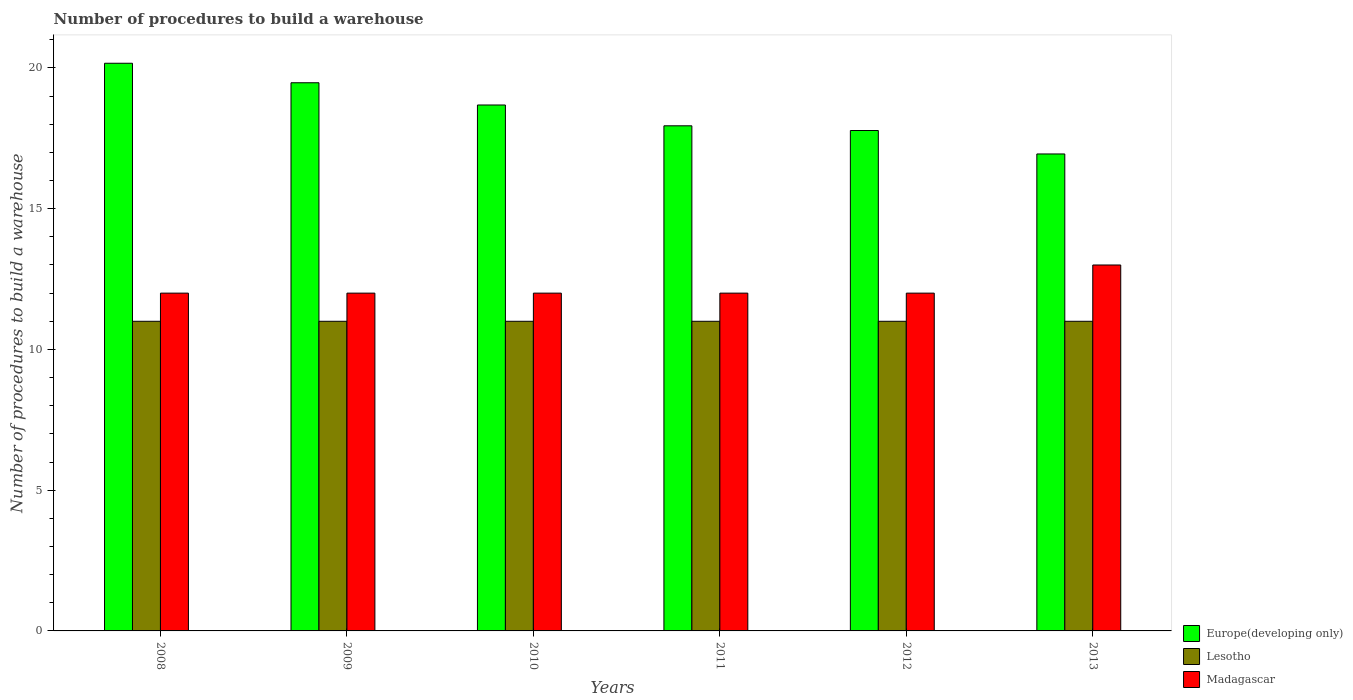How many different coloured bars are there?
Your response must be concise. 3. How many groups of bars are there?
Ensure brevity in your answer.  6. Are the number of bars per tick equal to the number of legend labels?
Ensure brevity in your answer.  Yes. Are the number of bars on each tick of the X-axis equal?
Ensure brevity in your answer.  Yes. How many bars are there on the 5th tick from the left?
Give a very brief answer. 3. What is the label of the 3rd group of bars from the left?
Ensure brevity in your answer.  2010. In how many cases, is the number of bars for a given year not equal to the number of legend labels?
Your response must be concise. 0. What is the number of procedures to build a warehouse in in Madagascar in 2009?
Ensure brevity in your answer.  12. Across all years, what is the maximum number of procedures to build a warehouse in in Madagascar?
Your answer should be compact. 13. Across all years, what is the minimum number of procedures to build a warehouse in in Europe(developing only)?
Your answer should be compact. 16.94. In which year was the number of procedures to build a warehouse in in Madagascar maximum?
Provide a short and direct response. 2013. What is the total number of procedures to build a warehouse in in Europe(developing only) in the graph?
Offer a terse response. 110.99. What is the difference between the number of procedures to build a warehouse in in Europe(developing only) in 2009 and that in 2011?
Provide a succinct answer. 1.53. What is the difference between the number of procedures to build a warehouse in in Madagascar in 2008 and the number of procedures to build a warehouse in in Europe(developing only) in 2012?
Your answer should be compact. -5.78. What is the average number of procedures to build a warehouse in in Madagascar per year?
Keep it short and to the point. 12.17. In the year 2008, what is the difference between the number of procedures to build a warehouse in in Europe(developing only) and number of procedures to build a warehouse in in Madagascar?
Ensure brevity in your answer.  8.17. In how many years, is the number of procedures to build a warehouse in in Lesotho greater than 3?
Provide a short and direct response. 6. What is the ratio of the number of procedures to build a warehouse in in Europe(developing only) in 2011 to that in 2012?
Your answer should be very brief. 1.01. Is the number of procedures to build a warehouse in in Lesotho in 2010 less than that in 2011?
Your answer should be compact. No. Is the difference between the number of procedures to build a warehouse in in Europe(developing only) in 2009 and 2011 greater than the difference between the number of procedures to build a warehouse in in Madagascar in 2009 and 2011?
Your response must be concise. Yes. What is the difference between the highest and the lowest number of procedures to build a warehouse in in Madagascar?
Ensure brevity in your answer.  1. In how many years, is the number of procedures to build a warehouse in in Madagascar greater than the average number of procedures to build a warehouse in in Madagascar taken over all years?
Ensure brevity in your answer.  1. Is the sum of the number of procedures to build a warehouse in in Lesotho in 2010 and 2013 greater than the maximum number of procedures to build a warehouse in in Madagascar across all years?
Provide a succinct answer. Yes. What does the 2nd bar from the left in 2013 represents?
Provide a succinct answer. Lesotho. What does the 2nd bar from the right in 2012 represents?
Provide a short and direct response. Lesotho. How many years are there in the graph?
Ensure brevity in your answer.  6. What is the difference between two consecutive major ticks on the Y-axis?
Keep it short and to the point. 5. Does the graph contain grids?
Provide a succinct answer. No. What is the title of the graph?
Offer a very short reply. Number of procedures to build a warehouse. Does "Congo (Republic)" appear as one of the legend labels in the graph?
Ensure brevity in your answer.  No. What is the label or title of the X-axis?
Offer a terse response. Years. What is the label or title of the Y-axis?
Your response must be concise. Number of procedures to build a warehouse. What is the Number of procedures to build a warehouse of Europe(developing only) in 2008?
Provide a succinct answer. 20.17. What is the Number of procedures to build a warehouse of Europe(developing only) in 2009?
Your response must be concise. 19.47. What is the Number of procedures to build a warehouse in Lesotho in 2009?
Your answer should be very brief. 11. What is the Number of procedures to build a warehouse in Madagascar in 2009?
Offer a terse response. 12. What is the Number of procedures to build a warehouse of Europe(developing only) in 2010?
Your response must be concise. 18.68. What is the Number of procedures to build a warehouse of Madagascar in 2010?
Make the answer very short. 12. What is the Number of procedures to build a warehouse of Europe(developing only) in 2011?
Your answer should be very brief. 17.94. What is the Number of procedures to build a warehouse of Lesotho in 2011?
Keep it short and to the point. 11. What is the Number of procedures to build a warehouse in Madagascar in 2011?
Provide a succinct answer. 12. What is the Number of procedures to build a warehouse of Europe(developing only) in 2012?
Offer a very short reply. 17.78. What is the Number of procedures to build a warehouse in Madagascar in 2012?
Your answer should be compact. 12. What is the Number of procedures to build a warehouse in Europe(developing only) in 2013?
Provide a succinct answer. 16.94. Across all years, what is the maximum Number of procedures to build a warehouse of Europe(developing only)?
Provide a succinct answer. 20.17. Across all years, what is the maximum Number of procedures to build a warehouse in Lesotho?
Your answer should be compact. 11. Across all years, what is the maximum Number of procedures to build a warehouse in Madagascar?
Your answer should be very brief. 13. Across all years, what is the minimum Number of procedures to build a warehouse in Europe(developing only)?
Your response must be concise. 16.94. Across all years, what is the minimum Number of procedures to build a warehouse of Lesotho?
Your answer should be compact. 11. Across all years, what is the minimum Number of procedures to build a warehouse of Madagascar?
Your answer should be compact. 12. What is the total Number of procedures to build a warehouse of Europe(developing only) in the graph?
Your response must be concise. 110.99. What is the total Number of procedures to build a warehouse of Lesotho in the graph?
Ensure brevity in your answer.  66. What is the difference between the Number of procedures to build a warehouse of Europe(developing only) in 2008 and that in 2009?
Provide a succinct answer. 0.69. What is the difference between the Number of procedures to build a warehouse in Madagascar in 2008 and that in 2009?
Ensure brevity in your answer.  0. What is the difference between the Number of procedures to build a warehouse in Europe(developing only) in 2008 and that in 2010?
Give a very brief answer. 1.48. What is the difference between the Number of procedures to build a warehouse in Europe(developing only) in 2008 and that in 2011?
Your answer should be very brief. 2.22. What is the difference between the Number of procedures to build a warehouse in Lesotho in 2008 and that in 2011?
Ensure brevity in your answer.  0. What is the difference between the Number of procedures to build a warehouse in Madagascar in 2008 and that in 2011?
Your answer should be compact. 0. What is the difference between the Number of procedures to build a warehouse of Europe(developing only) in 2008 and that in 2012?
Provide a short and direct response. 2.39. What is the difference between the Number of procedures to build a warehouse of Madagascar in 2008 and that in 2012?
Provide a succinct answer. 0. What is the difference between the Number of procedures to build a warehouse in Europe(developing only) in 2008 and that in 2013?
Make the answer very short. 3.22. What is the difference between the Number of procedures to build a warehouse of Madagascar in 2008 and that in 2013?
Your answer should be compact. -1. What is the difference between the Number of procedures to build a warehouse in Europe(developing only) in 2009 and that in 2010?
Ensure brevity in your answer.  0.79. What is the difference between the Number of procedures to build a warehouse in Lesotho in 2009 and that in 2010?
Your answer should be compact. 0. What is the difference between the Number of procedures to build a warehouse of Europe(developing only) in 2009 and that in 2011?
Your response must be concise. 1.53. What is the difference between the Number of procedures to build a warehouse in Lesotho in 2009 and that in 2011?
Keep it short and to the point. 0. What is the difference between the Number of procedures to build a warehouse of Europe(developing only) in 2009 and that in 2012?
Ensure brevity in your answer.  1.7. What is the difference between the Number of procedures to build a warehouse in Madagascar in 2009 and that in 2012?
Make the answer very short. 0. What is the difference between the Number of procedures to build a warehouse in Europe(developing only) in 2009 and that in 2013?
Your response must be concise. 2.53. What is the difference between the Number of procedures to build a warehouse in Lesotho in 2009 and that in 2013?
Offer a terse response. 0. What is the difference between the Number of procedures to build a warehouse of Europe(developing only) in 2010 and that in 2011?
Give a very brief answer. 0.74. What is the difference between the Number of procedures to build a warehouse in Lesotho in 2010 and that in 2011?
Provide a short and direct response. 0. What is the difference between the Number of procedures to build a warehouse in Madagascar in 2010 and that in 2011?
Make the answer very short. 0. What is the difference between the Number of procedures to build a warehouse in Europe(developing only) in 2010 and that in 2012?
Keep it short and to the point. 0.91. What is the difference between the Number of procedures to build a warehouse of Europe(developing only) in 2010 and that in 2013?
Make the answer very short. 1.74. What is the difference between the Number of procedures to build a warehouse of Lesotho in 2010 and that in 2013?
Your answer should be compact. 0. What is the difference between the Number of procedures to build a warehouse of Madagascar in 2010 and that in 2013?
Your answer should be very brief. -1. What is the difference between the Number of procedures to build a warehouse of Europe(developing only) in 2011 and that in 2012?
Offer a terse response. 0.17. What is the difference between the Number of procedures to build a warehouse of Lesotho in 2011 and that in 2012?
Your response must be concise. 0. What is the difference between the Number of procedures to build a warehouse in Madagascar in 2011 and that in 2012?
Give a very brief answer. 0. What is the difference between the Number of procedures to build a warehouse of Europe(developing only) in 2011 and that in 2013?
Your answer should be very brief. 1. What is the difference between the Number of procedures to build a warehouse in Madagascar in 2011 and that in 2013?
Your answer should be very brief. -1. What is the difference between the Number of procedures to build a warehouse of Lesotho in 2012 and that in 2013?
Your answer should be compact. 0. What is the difference between the Number of procedures to build a warehouse in Europe(developing only) in 2008 and the Number of procedures to build a warehouse in Lesotho in 2009?
Your answer should be compact. 9.17. What is the difference between the Number of procedures to build a warehouse in Europe(developing only) in 2008 and the Number of procedures to build a warehouse in Madagascar in 2009?
Give a very brief answer. 8.17. What is the difference between the Number of procedures to build a warehouse in Lesotho in 2008 and the Number of procedures to build a warehouse in Madagascar in 2009?
Offer a very short reply. -1. What is the difference between the Number of procedures to build a warehouse of Europe(developing only) in 2008 and the Number of procedures to build a warehouse of Lesotho in 2010?
Make the answer very short. 9.17. What is the difference between the Number of procedures to build a warehouse of Europe(developing only) in 2008 and the Number of procedures to build a warehouse of Madagascar in 2010?
Provide a succinct answer. 8.17. What is the difference between the Number of procedures to build a warehouse in Lesotho in 2008 and the Number of procedures to build a warehouse in Madagascar in 2010?
Give a very brief answer. -1. What is the difference between the Number of procedures to build a warehouse of Europe(developing only) in 2008 and the Number of procedures to build a warehouse of Lesotho in 2011?
Your answer should be very brief. 9.17. What is the difference between the Number of procedures to build a warehouse of Europe(developing only) in 2008 and the Number of procedures to build a warehouse of Madagascar in 2011?
Offer a terse response. 8.17. What is the difference between the Number of procedures to build a warehouse of Europe(developing only) in 2008 and the Number of procedures to build a warehouse of Lesotho in 2012?
Ensure brevity in your answer.  9.17. What is the difference between the Number of procedures to build a warehouse in Europe(developing only) in 2008 and the Number of procedures to build a warehouse in Madagascar in 2012?
Give a very brief answer. 8.17. What is the difference between the Number of procedures to build a warehouse of Europe(developing only) in 2008 and the Number of procedures to build a warehouse of Lesotho in 2013?
Offer a terse response. 9.17. What is the difference between the Number of procedures to build a warehouse in Europe(developing only) in 2008 and the Number of procedures to build a warehouse in Madagascar in 2013?
Keep it short and to the point. 7.17. What is the difference between the Number of procedures to build a warehouse of Lesotho in 2008 and the Number of procedures to build a warehouse of Madagascar in 2013?
Provide a short and direct response. -2. What is the difference between the Number of procedures to build a warehouse of Europe(developing only) in 2009 and the Number of procedures to build a warehouse of Lesotho in 2010?
Your response must be concise. 8.47. What is the difference between the Number of procedures to build a warehouse in Europe(developing only) in 2009 and the Number of procedures to build a warehouse in Madagascar in 2010?
Your response must be concise. 7.47. What is the difference between the Number of procedures to build a warehouse of Europe(developing only) in 2009 and the Number of procedures to build a warehouse of Lesotho in 2011?
Your answer should be very brief. 8.47. What is the difference between the Number of procedures to build a warehouse of Europe(developing only) in 2009 and the Number of procedures to build a warehouse of Madagascar in 2011?
Your response must be concise. 7.47. What is the difference between the Number of procedures to build a warehouse of Lesotho in 2009 and the Number of procedures to build a warehouse of Madagascar in 2011?
Ensure brevity in your answer.  -1. What is the difference between the Number of procedures to build a warehouse of Europe(developing only) in 2009 and the Number of procedures to build a warehouse of Lesotho in 2012?
Your response must be concise. 8.47. What is the difference between the Number of procedures to build a warehouse of Europe(developing only) in 2009 and the Number of procedures to build a warehouse of Madagascar in 2012?
Your response must be concise. 7.47. What is the difference between the Number of procedures to build a warehouse of Lesotho in 2009 and the Number of procedures to build a warehouse of Madagascar in 2012?
Your answer should be compact. -1. What is the difference between the Number of procedures to build a warehouse of Europe(developing only) in 2009 and the Number of procedures to build a warehouse of Lesotho in 2013?
Provide a short and direct response. 8.47. What is the difference between the Number of procedures to build a warehouse in Europe(developing only) in 2009 and the Number of procedures to build a warehouse in Madagascar in 2013?
Offer a terse response. 6.47. What is the difference between the Number of procedures to build a warehouse of Lesotho in 2009 and the Number of procedures to build a warehouse of Madagascar in 2013?
Your answer should be compact. -2. What is the difference between the Number of procedures to build a warehouse in Europe(developing only) in 2010 and the Number of procedures to build a warehouse in Lesotho in 2011?
Offer a very short reply. 7.68. What is the difference between the Number of procedures to build a warehouse of Europe(developing only) in 2010 and the Number of procedures to build a warehouse of Madagascar in 2011?
Provide a succinct answer. 6.68. What is the difference between the Number of procedures to build a warehouse of Lesotho in 2010 and the Number of procedures to build a warehouse of Madagascar in 2011?
Ensure brevity in your answer.  -1. What is the difference between the Number of procedures to build a warehouse in Europe(developing only) in 2010 and the Number of procedures to build a warehouse in Lesotho in 2012?
Offer a terse response. 7.68. What is the difference between the Number of procedures to build a warehouse of Europe(developing only) in 2010 and the Number of procedures to build a warehouse of Madagascar in 2012?
Make the answer very short. 6.68. What is the difference between the Number of procedures to build a warehouse in Lesotho in 2010 and the Number of procedures to build a warehouse in Madagascar in 2012?
Make the answer very short. -1. What is the difference between the Number of procedures to build a warehouse of Europe(developing only) in 2010 and the Number of procedures to build a warehouse of Lesotho in 2013?
Your answer should be very brief. 7.68. What is the difference between the Number of procedures to build a warehouse in Europe(developing only) in 2010 and the Number of procedures to build a warehouse in Madagascar in 2013?
Provide a succinct answer. 5.68. What is the difference between the Number of procedures to build a warehouse in Europe(developing only) in 2011 and the Number of procedures to build a warehouse in Lesotho in 2012?
Make the answer very short. 6.94. What is the difference between the Number of procedures to build a warehouse of Europe(developing only) in 2011 and the Number of procedures to build a warehouse of Madagascar in 2012?
Make the answer very short. 5.94. What is the difference between the Number of procedures to build a warehouse in Europe(developing only) in 2011 and the Number of procedures to build a warehouse in Lesotho in 2013?
Offer a terse response. 6.94. What is the difference between the Number of procedures to build a warehouse of Europe(developing only) in 2011 and the Number of procedures to build a warehouse of Madagascar in 2013?
Keep it short and to the point. 4.94. What is the difference between the Number of procedures to build a warehouse of Europe(developing only) in 2012 and the Number of procedures to build a warehouse of Lesotho in 2013?
Provide a short and direct response. 6.78. What is the difference between the Number of procedures to build a warehouse in Europe(developing only) in 2012 and the Number of procedures to build a warehouse in Madagascar in 2013?
Your answer should be compact. 4.78. What is the difference between the Number of procedures to build a warehouse of Lesotho in 2012 and the Number of procedures to build a warehouse of Madagascar in 2013?
Offer a very short reply. -2. What is the average Number of procedures to build a warehouse in Europe(developing only) per year?
Your answer should be very brief. 18.5. What is the average Number of procedures to build a warehouse of Madagascar per year?
Your response must be concise. 12.17. In the year 2008, what is the difference between the Number of procedures to build a warehouse of Europe(developing only) and Number of procedures to build a warehouse of Lesotho?
Provide a succinct answer. 9.17. In the year 2008, what is the difference between the Number of procedures to build a warehouse of Europe(developing only) and Number of procedures to build a warehouse of Madagascar?
Offer a terse response. 8.17. In the year 2009, what is the difference between the Number of procedures to build a warehouse of Europe(developing only) and Number of procedures to build a warehouse of Lesotho?
Provide a short and direct response. 8.47. In the year 2009, what is the difference between the Number of procedures to build a warehouse in Europe(developing only) and Number of procedures to build a warehouse in Madagascar?
Offer a very short reply. 7.47. In the year 2009, what is the difference between the Number of procedures to build a warehouse in Lesotho and Number of procedures to build a warehouse in Madagascar?
Your answer should be very brief. -1. In the year 2010, what is the difference between the Number of procedures to build a warehouse in Europe(developing only) and Number of procedures to build a warehouse in Lesotho?
Provide a succinct answer. 7.68. In the year 2010, what is the difference between the Number of procedures to build a warehouse of Europe(developing only) and Number of procedures to build a warehouse of Madagascar?
Provide a succinct answer. 6.68. In the year 2010, what is the difference between the Number of procedures to build a warehouse in Lesotho and Number of procedures to build a warehouse in Madagascar?
Ensure brevity in your answer.  -1. In the year 2011, what is the difference between the Number of procedures to build a warehouse of Europe(developing only) and Number of procedures to build a warehouse of Lesotho?
Your answer should be compact. 6.94. In the year 2011, what is the difference between the Number of procedures to build a warehouse of Europe(developing only) and Number of procedures to build a warehouse of Madagascar?
Make the answer very short. 5.94. In the year 2011, what is the difference between the Number of procedures to build a warehouse in Lesotho and Number of procedures to build a warehouse in Madagascar?
Provide a succinct answer. -1. In the year 2012, what is the difference between the Number of procedures to build a warehouse of Europe(developing only) and Number of procedures to build a warehouse of Lesotho?
Your answer should be compact. 6.78. In the year 2012, what is the difference between the Number of procedures to build a warehouse in Europe(developing only) and Number of procedures to build a warehouse in Madagascar?
Make the answer very short. 5.78. In the year 2012, what is the difference between the Number of procedures to build a warehouse of Lesotho and Number of procedures to build a warehouse of Madagascar?
Your response must be concise. -1. In the year 2013, what is the difference between the Number of procedures to build a warehouse in Europe(developing only) and Number of procedures to build a warehouse in Lesotho?
Keep it short and to the point. 5.94. In the year 2013, what is the difference between the Number of procedures to build a warehouse of Europe(developing only) and Number of procedures to build a warehouse of Madagascar?
Give a very brief answer. 3.94. What is the ratio of the Number of procedures to build a warehouse in Europe(developing only) in 2008 to that in 2009?
Your answer should be compact. 1.04. What is the ratio of the Number of procedures to build a warehouse of Europe(developing only) in 2008 to that in 2010?
Ensure brevity in your answer.  1.08. What is the ratio of the Number of procedures to build a warehouse in Europe(developing only) in 2008 to that in 2011?
Ensure brevity in your answer.  1.12. What is the ratio of the Number of procedures to build a warehouse of Lesotho in 2008 to that in 2011?
Give a very brief answer. 1. What is the ratio of the Number of procedures to build a warehouse of Europe(developing only) in 2008 to that in 2012?
Make the answer very short. 1.13. What is the ratio of the Number of procedures to build a warehouse of Lesotho in 2008 to that in 2012?
Provide a succinct answer. 1. What is the ratio of the Number of procedures to build a warehouse in Madagascar in 2008 to that in 2012?
Provide a short and direct response. 1. What is the ratio of the Number of procedures to build a warehouse of Europe(developing only) in 2008 to that in 2013?
Provide a succinct answer. 1.19. What is the ratio of the Number of procedures to build a warehouse of Lesotho in 2008 to that in 2013?
Offer a very short reply. 1. What is the ratio of the Number of procedures to build a warehouse of Europe(developing only) in 2009 to that in 2010?
Make the answer very short. 1.04. What is the ratio of the Number of procedures to build a warehouse in Madagascar in 2009 to that in 2010?
Give a very brief answer. 1. What is the ratio of the Number of procedures to build a warehouse of Europe(developing only) in 2009 to that in 2011?
Your answer should be very brief. 1.09. What is the ratio of the Number of procedures to build a warehouse of Europe(developing only) in 2009 to that in 2012?
Ensure brevity in your answer.  1.1. What is the ratio of the Number of procedures to build a warehouse of Lesotho in 2009 to that in 2012?
Give a very brief answer. 1. What is the ratio of the Number of procedures to build a warehouse of Europe(developing only) in 2009 to that in 2013?
Provide a short and direct response. 1.15. What is the ratio of the Number of procedures to build a warehouse in Lesotho in 2009 to that in 2013?
Offer a very short reply. 1. What is the ratio of the Number of procedures to build a warehouse of Madagascar in 2009 to that in 2013?
Give a very brief answer. 0.92. What is the ratio of the Number of procedures to build a warehouse in Europe(developing only) in 2010 to that in 2011?
Offer a terse response. 1.04. What is the ratio of the Number of procedures to build a warehouse of Europe(developing only) in 2010 to that in 2012?
Your answer should be compact. 1.05. What is the ratio of the Number of procedures to build a warehouse of Lesotho in 2010 to that in 2012?
Offer a very short reply. 1. What is the ratio of the Number of procedures to build a warehouse in Madagascar in 2010 to that in 2012?
Offer a terse response. 1. What is the ratio of the Number of procedures to build a warehouse in Europe(developing only) in 2010 to that in 2013?
Your answer should be compact. 1.1. What is the ratio of the Number of procedures to build a warehouse of Europe(developing only) in 2011 to that in 2012?
Offer a very short reply. 1.01. What is the ratio of the Number of procedures to build a warehouse in Lesotho in 2011 to that in 2012?
Provide a succinct answer. 1. What is the ratio of the Number of procedures to build a warehouse of Madagascar in 2011 to that in 2012?
Keep it short and to the point. 1. What is the ratio of the Number of procedures to build a warehouse of Europe(developing only) in 2011 to that in 2013?
Keep it short and to the point. 1.06. What is the ratio of the Number of procedures to build a warehouse in Europe(developing only) in 2012 to that in 2013?
Your answer should be compact. 1.05. What is the difference between the highest and the second highest Number of procedures to build a warehouse in Europe(developing only)?
Your answer should be very brief. 0.69. What is the difference between the highest and the second highest Number of procedures to build a warehouse of Lesotho?
Make the answer very short. 0. What is the difference between the highest and the second highest Number of procedures to build a warehouse of Madagascar?
Your answer should be very brief. 1. What is the difference between the highest and the lowest Number of procedures to build a warehouse in Europe(developing only)?
Keep it short and to the point. 3.22. What is the difference between the highest and the lowest Number of procedures to build a warehouse of Lesotho?
Your answer should be compact. 0. What is the difference between the highest and the lowest Number of procedures to build a warehouse in Madagascar?
Offer a very short reply. 1. 